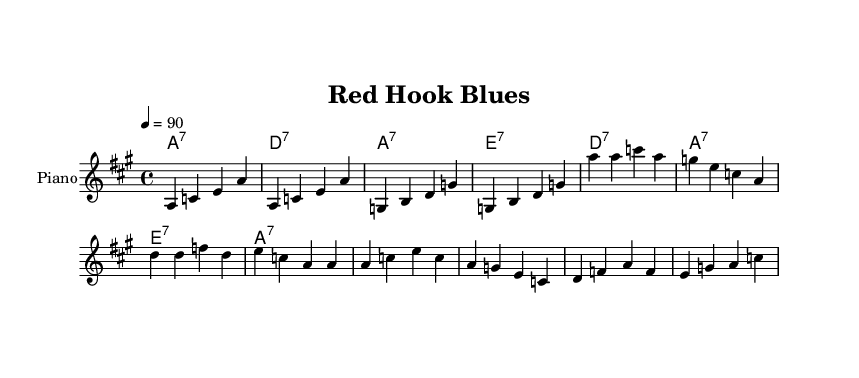What is the time signature of this music? The time signature is indicated at the beginning of the score and is represented as 4/4, meaning there are four beats per measure and the quarter note receives one beat.
Answer: 4/4 What is the key signature of this music? The key signature can be determined by looking at the key indicated at the start of the piece, which is A major. A major has three sharps: F#, C#, and G#.
Answer: A major What is the tempo marking for this piece? The tempo marking, which indicates the speed of the music, is specified as "4 = 90", meaning the quarter note is to be played at 90 beats per minute.
Answer: 90 How many measures are there in the melody? Counting the distinct groups of notes in the melody section reveals that there are a total of 8 measures in the provided melody line.
Answer: 8 What are the primary chords used in this Blues piece? The chords listed in the chord mode section show that the primary chords are A7, D7, and E7, which are typical chords in a Blues structure.
Answer: A7, D7, E7 What lyrical theme is presented in the song? The lyrics mention "Red Hook memories" and "New York blues," suggesting a nostalgic and urban theme associated with the singer’s experience in Red Hook, New York.
Answer: Nostalgic urban experience 